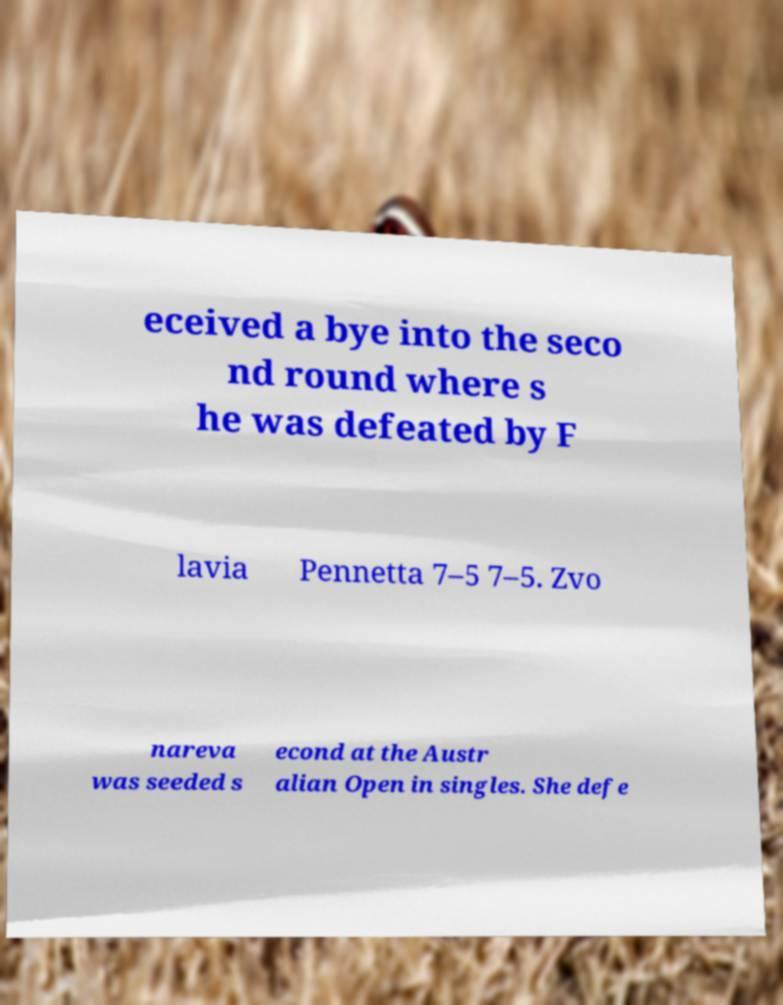For documentation purposes, I need the text within this image transcribed. Could you provide that? eceived a bye into the seco nd round where s he was defeated by F lavia Pennetta 7–5 7–5. Zvo nareva was seeded s econd at the Austr alian Open in singles. She defe 